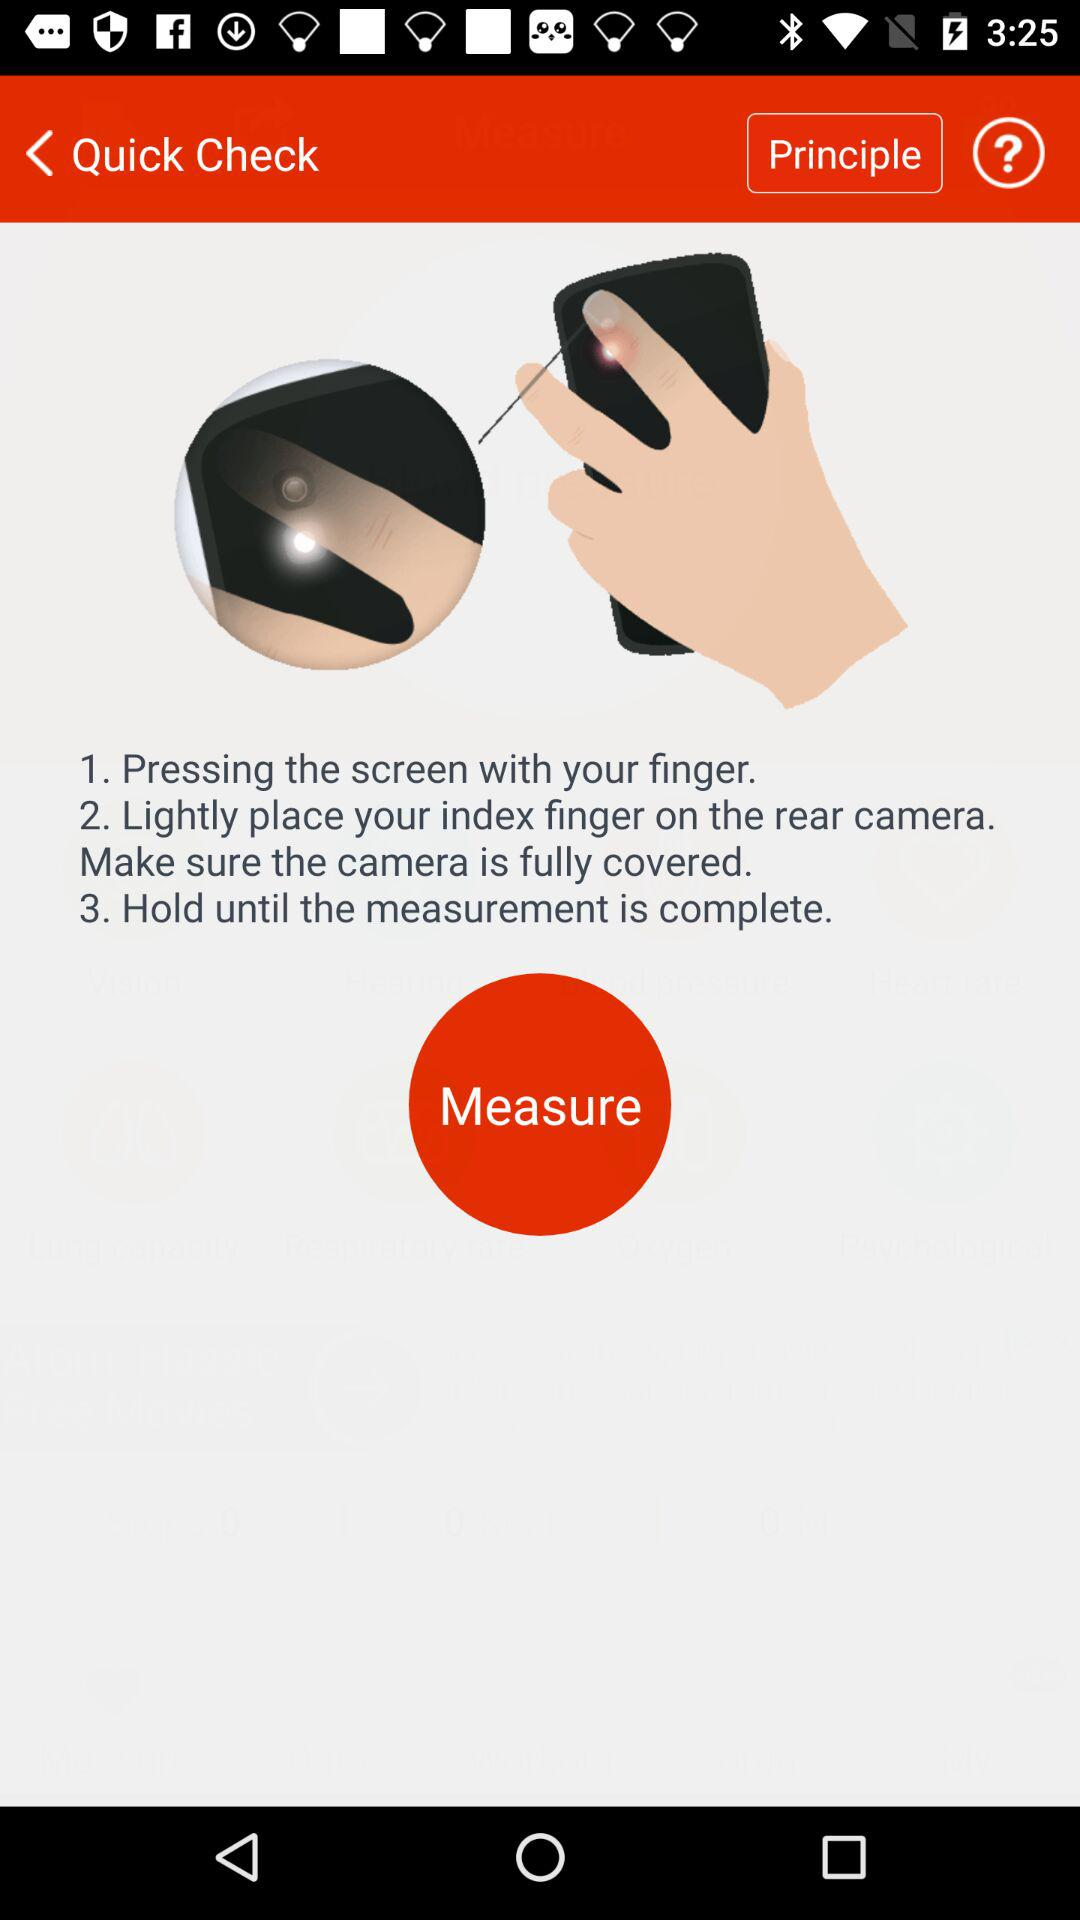How many steps are there to measure the ring size?
Answer the question using a single word or phrase. 3 